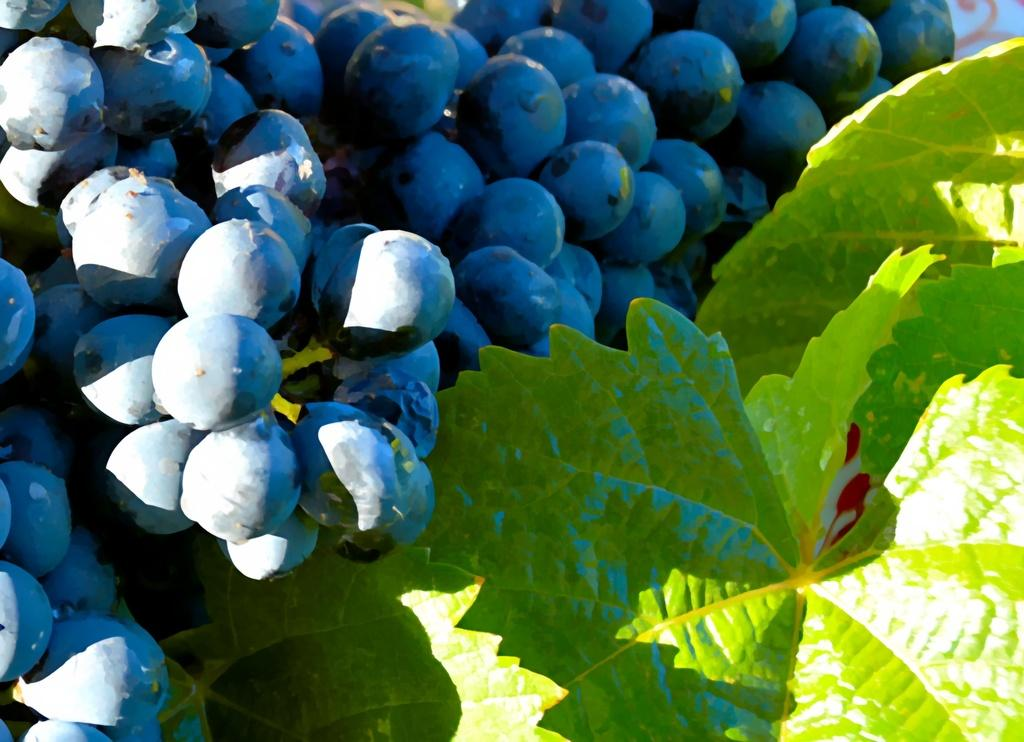What type of fruit is present in the image? There are grapes in the image. What else can be seen in the image besides the grapes? There are leaves in the image. What type of pail can be seen in the image? There is no pail present in the image. What is the aftermath of the grape harvest in the image? The image does not depict a grape harvest or its aftermath; it simply shows grapes and leaves. 